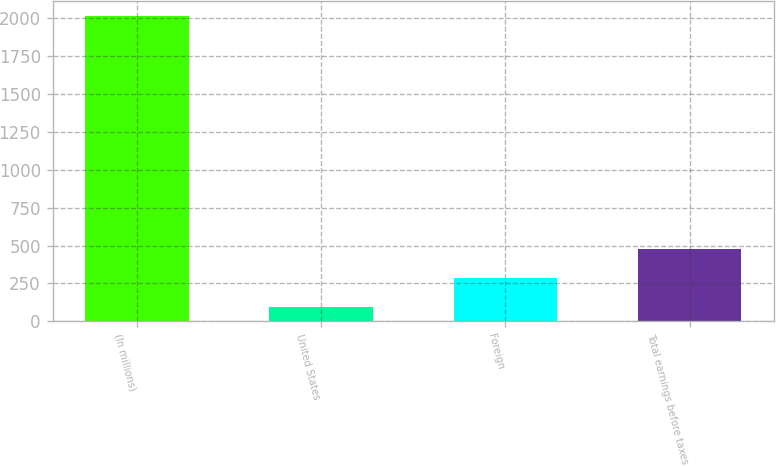Convert chart. <chart><loc_0><loc_0><loc_500><loc_500><bar_chart><fcel>(In millions)<fcel>United States<fcel>Foreign<fcel>Total earnings before taxes<nl><fcel>2017<fcel>93.7<fcel>286.03<fcel>478.36<nl></chart> 